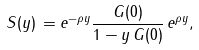Convert formula to latex. <formula><loc_0><loc_0><loc_500><loc_500>S ( y ) \, = e ^ { - \rho y } \frac { G ( 0 ) } { 1 - y \, G ( 0 ) } \, e ^ { \rho y } ,</formula> 